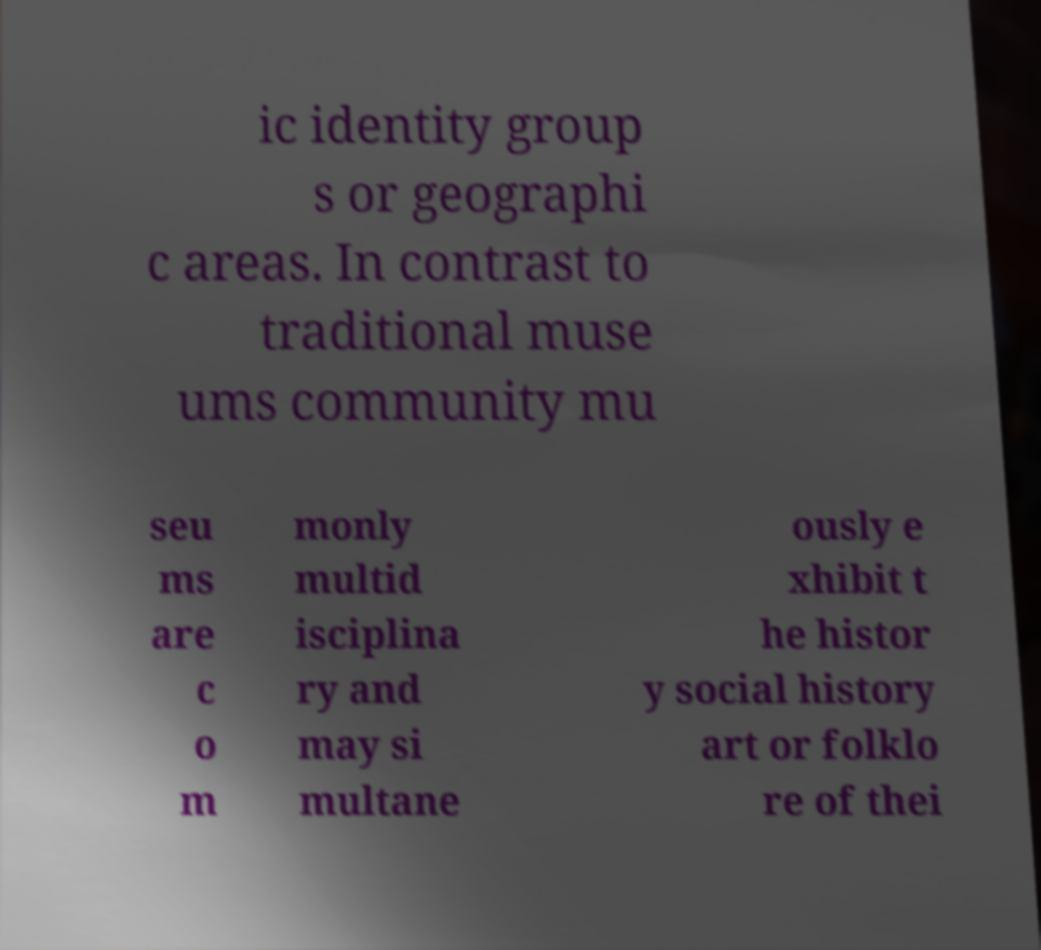Please identify and transcribe the text found in this image. ic identity group s or geographi c areas. In contrast to traditional muse ums community mu seu ms are c o m monly multid isciplina ry and may si multane ously e xhibit t he histor y social history art or folklo re of thei 